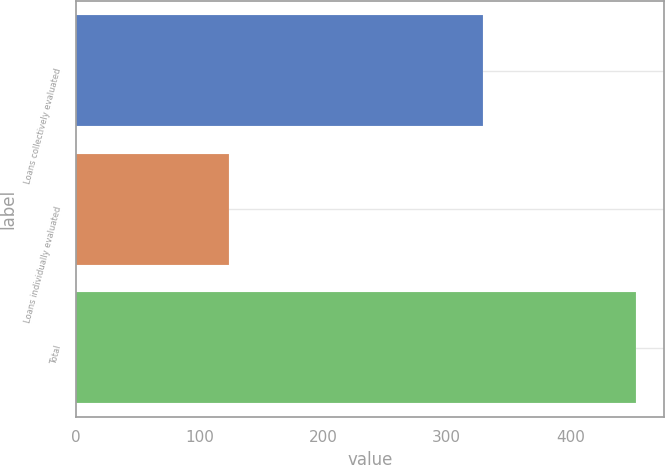Convert chart. <chart><loc_0><loc_0><loc_500><loc_500><bar_chart><fcel>Loans collectively evaluated<fcel>Loans individually evaluated<fcel>Total<nl><fcel>329<fcel>124<fcel>453<nl></chart> 